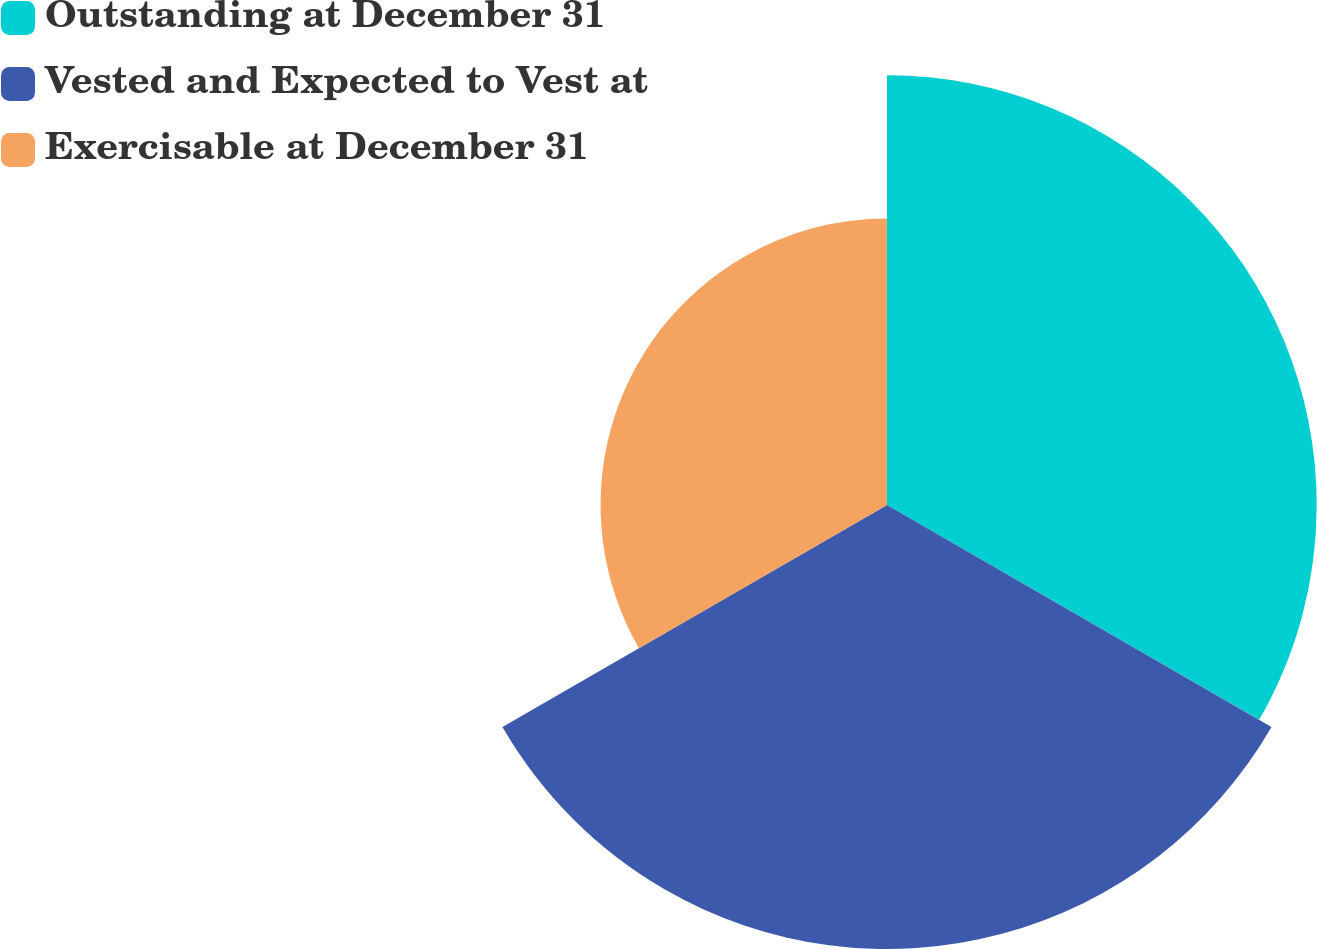Convert chart to OTSL. <chart><loc_0><loc_0><loc_500><loc_500><pie_chart><fcel>Outstanding at December 31<fcel>Vested and Expected to Vest at<fcel>Exercisable at December 31<nl><fcel>37.04%<fcel>38.27%<fcel>24.69%<nl></chart> 